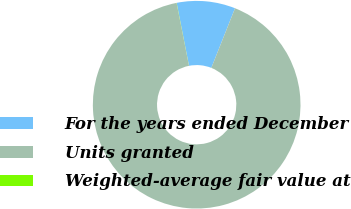<chart> <loc_0><loc_0><loc_500><loc_500><pie_chart><fcel>For the years ended December<fcel>Units granted<fcel>Weighted-average fair value at<nl><fcel>9.11%<fcel>90.87%<fcel>0.02%<nl></chart> 